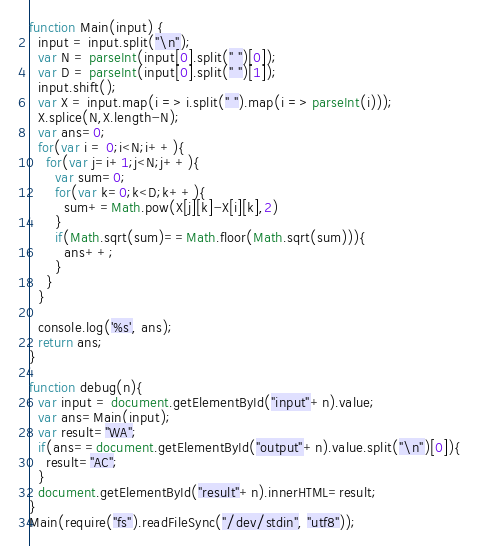<code> <loc_0><loc_0><loc_500><loc_500><_JavaScript_>

function Main(input) {
  input = input.split("\n");
  var N = parseInt(input[0].split(" ")[0]);
  var D = parseInt(input[0].split(" ")[1]);
  input.shift();
  var X = input.map(i => i.split(" ").map(i => parseInt(i)));
  X.splice(N,X.length-N);
  var ans=0;
  for(var i = 0;i<N;i++){
    for(var j=i+1;j<N;j++){
      var sum=0;
      for(var k=0;k<D;k++){
        sum+=Math.pow(X[j][k]-X[i][k],2)
      }
      if(Math.sqrt(sum)==Math.floor(Math.sqrt(sum))){
        ans++;
      }
    }
  }

  console.log('%s', ans);
  return ans;
}

function debug(n){
  var input = document.getElementById("input"+n).value;
  var ans=Main(input);
  var result="WA";
  if(ans==document.getElementById("output"+n).value.split("\n")[0]){
    result="AC";
  }
  document.getElementById("result"+n).innerHTML=result;
}
Main(require("fs").readFileSync("/dev/stdin", "utf8"));</code> 